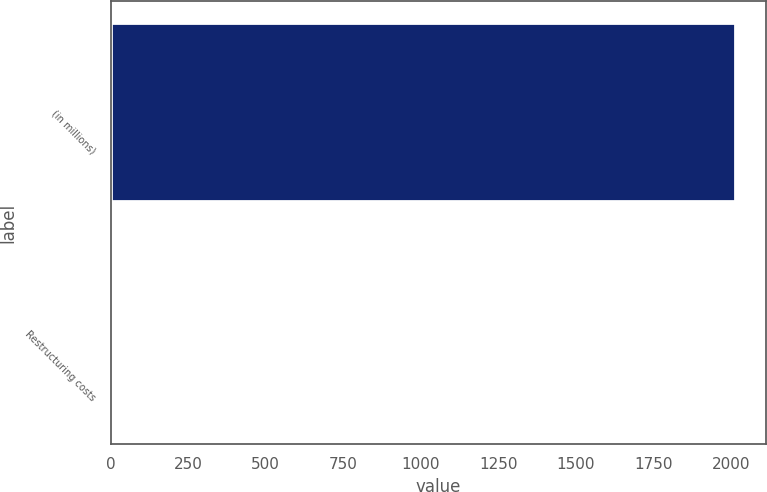Convert chart to OTSL. <chart><loc_0><loc_0><loc_500><loc_500><bar_chart><fcel>(in millions)<fcel>Restructuring costs<nl><fcel>2014<fcel>9<nl></chart> 